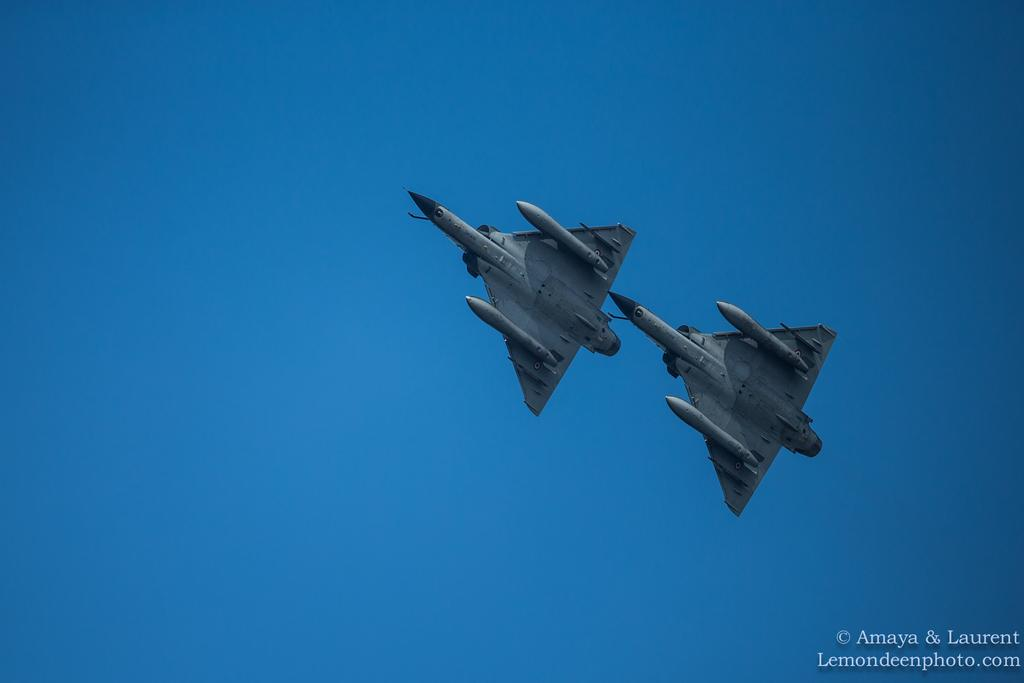<image>
Write a terse but informative summary of the picture. Photo of 2 fighter planes taken from lemondeenphoto.com 